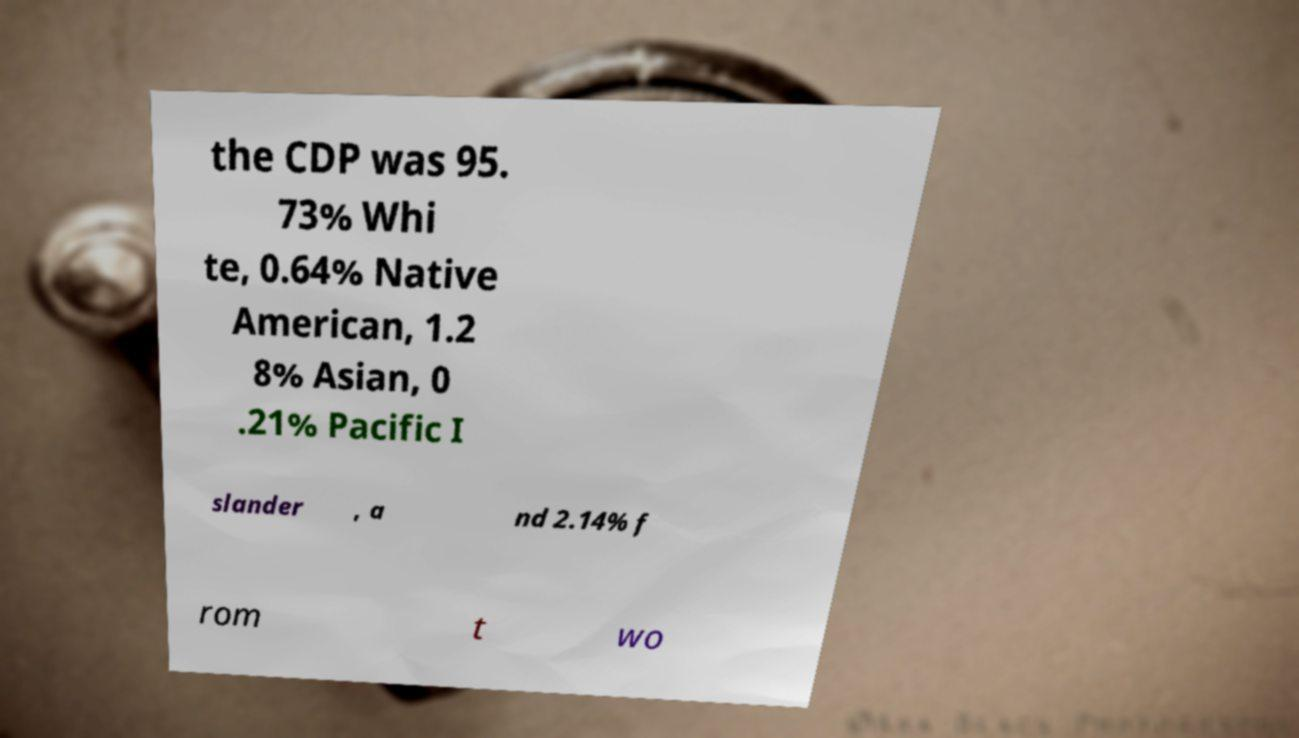Can you accurately transcribe the text from the provided image for me? the CDP was 95. 73% Whi te, 0.64% Native American, 1.2 8% Asian, 0 .21% Pacific I slander , a nd 2.14% f rom t wo 